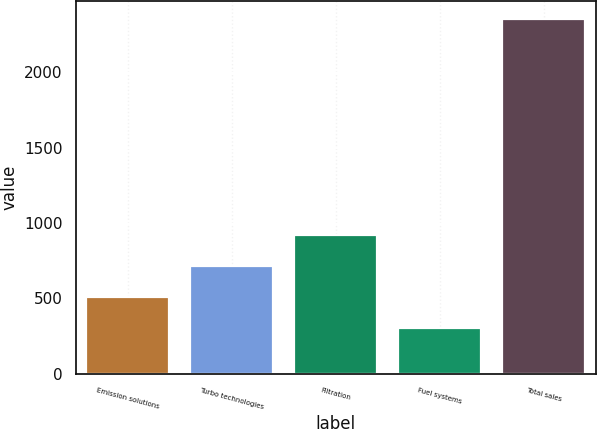Convert chart to OTSL. <chart><loc_0><loc_0><loc_500><loc_500><bar_chart><fcel>Emission solutions<fcel>Turbo technologies<fcel>Filtration<fcel>Fuel systems<fcel>Total sales<nl><fcel>510<fcel>715<fcel>920<fcel>305<fcel>2355<nl></chart> 